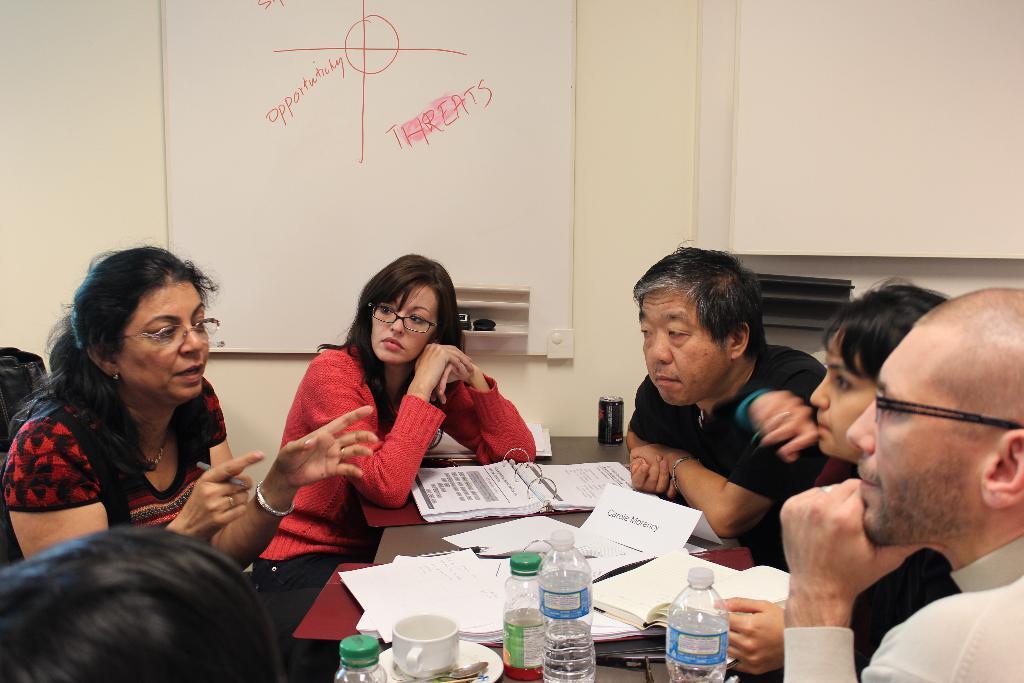In one or two sentences, can you explain what this image depicts? In this image, we can see a group of people are sitting. Here a woman is talking and holding a pen. In the middle, there is a table, so many things and objects are placed on it. Background there is a wallboard, some object. Here we can see few people are wearing glasses. 